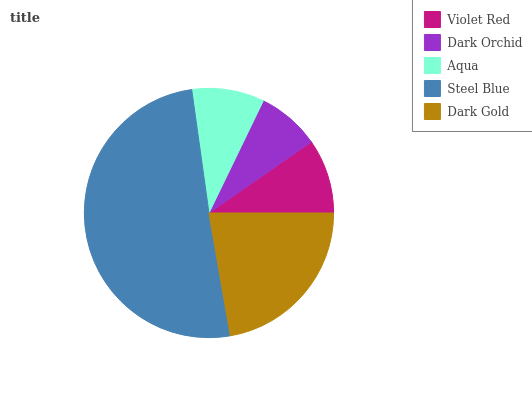Is Dark Orchid the minimum?
Answer yes or no. Yes. Is Steel Blue the maximum?
Answer yes or no. Yes. Is Aqua the minimum?
Answer yes or no. No. Is Aqua the maximum?
Answer yes or no. No. Is Aqua greater than Dark Orchid?
Answer yes or no. Yes. Is Dark Orchid less than Aqua?
Answer yes or no. Yes. Is Dark Orchid greater than Aqua?
Answer yes or no. No. Is Aqua less than Dark Orchid?
Answer yes or no. No. Is Violet Red the high median?
Answer yes or no. Yes. Is Violet Red the low median?
Answer yes or no. Yes. Is Aqua the high median?
Answer yes or no. No. Is Dark Gold the low median?
Answer yes or no. No. 